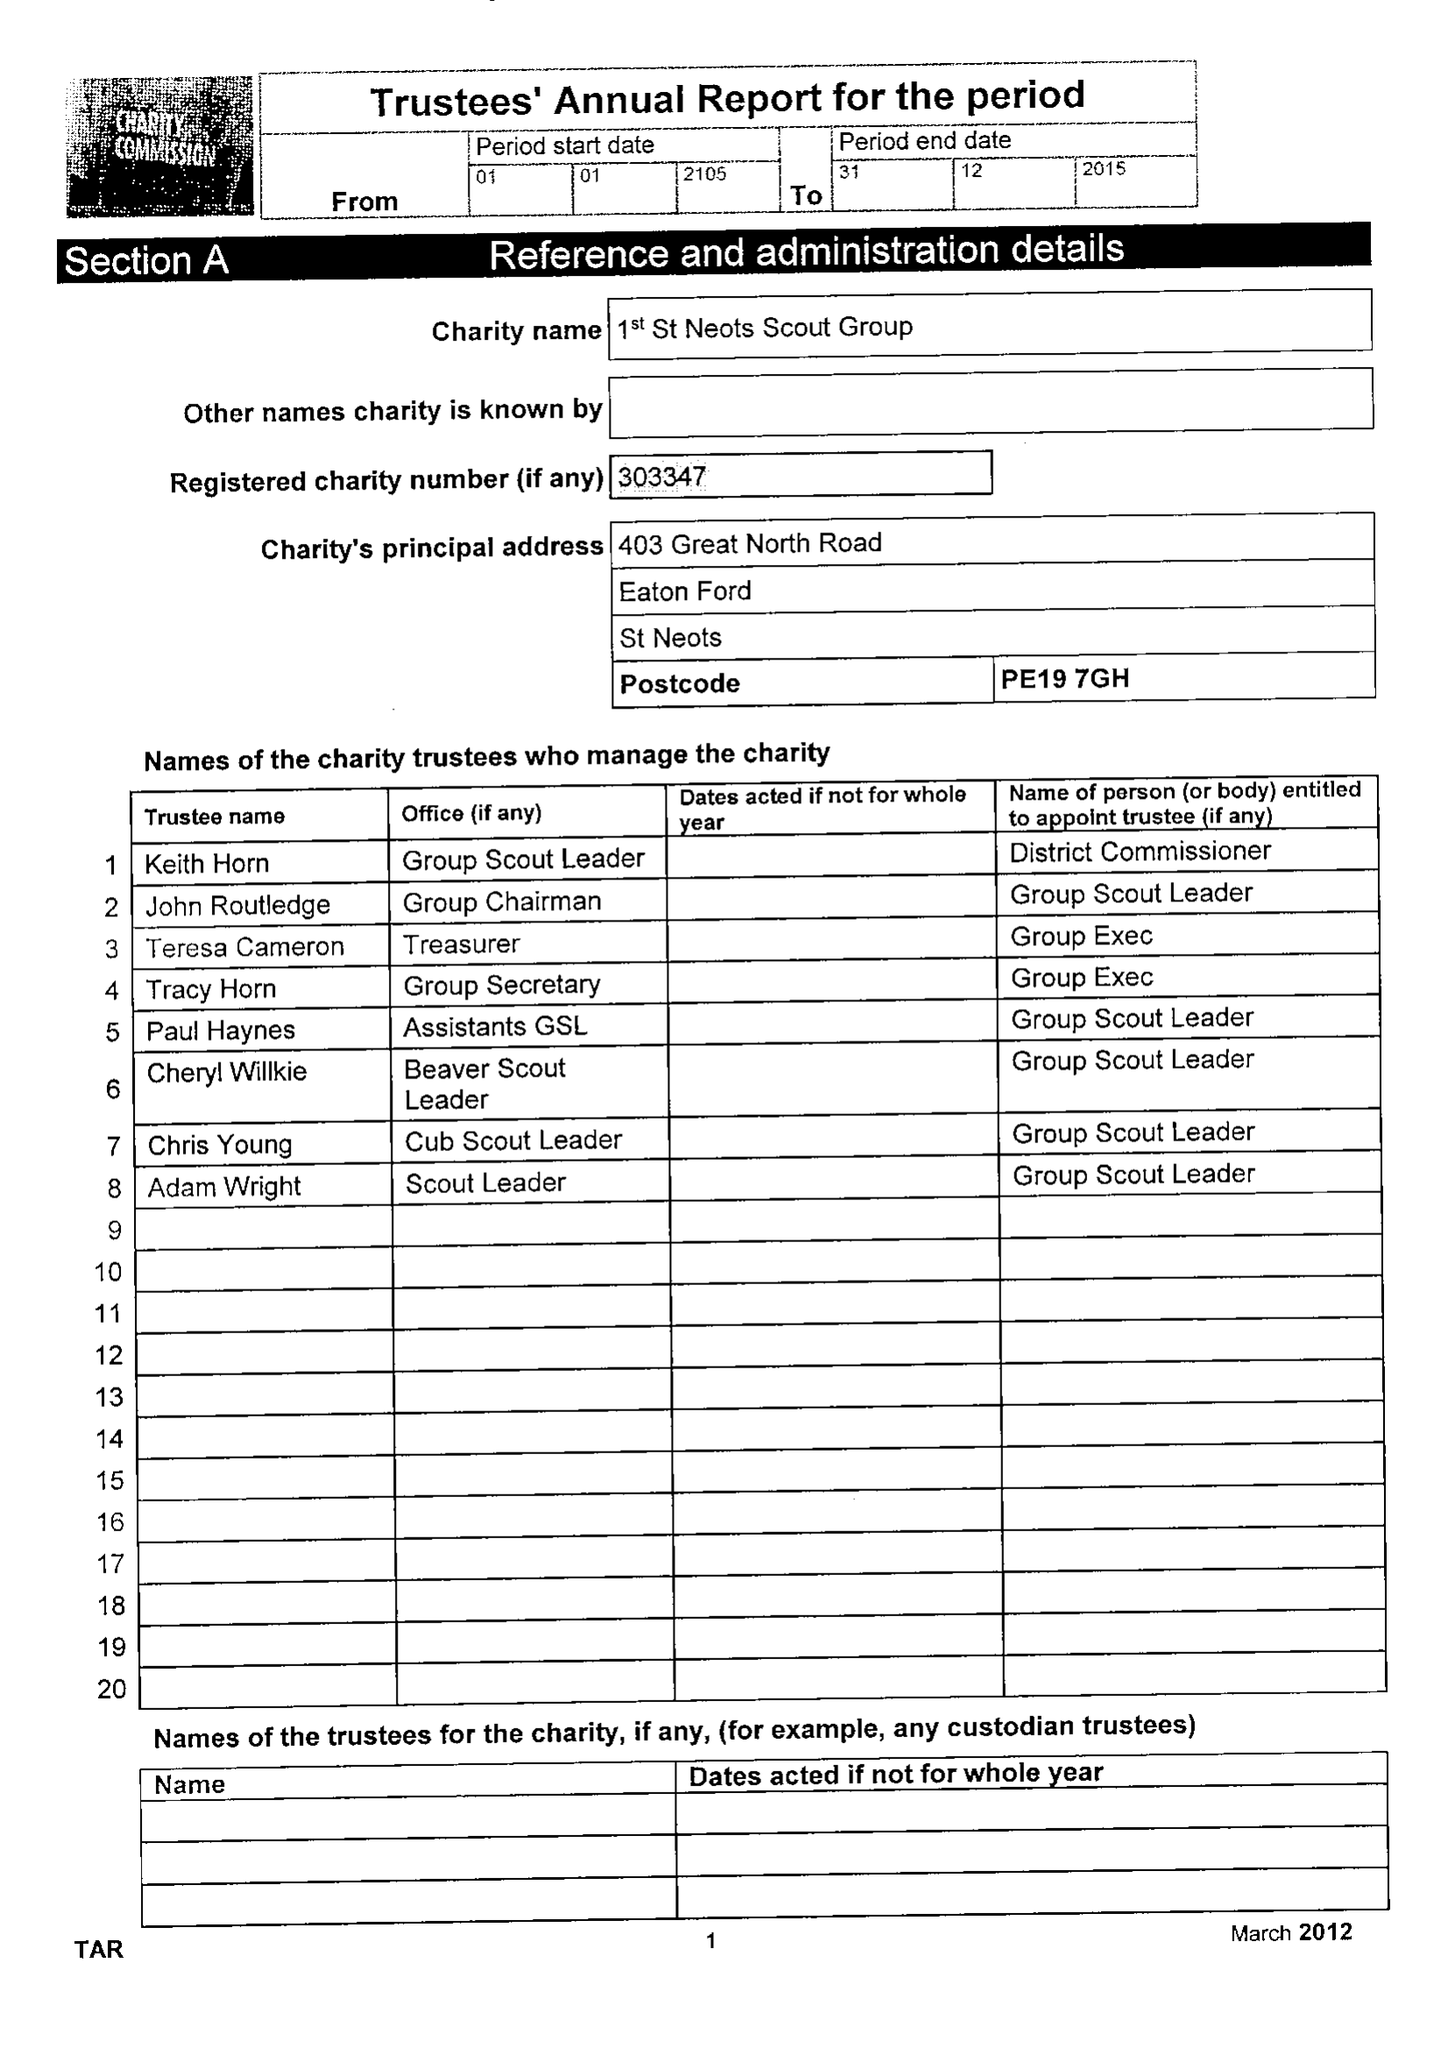What is the value for the address__postcode?
Answer the question using a single word or phrase. PE19 7GH 